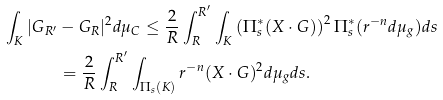<formula> <loc_0><loc_0><loc_500><loc_500>\int _ { K } | G _ { R ^ { \prime } } & - G _ { R } | ^ { 2 } d \mu _ { C } \leq \frac { 2 } { R } \int _ { R } ^ { R ^ { \prime } } \int _ { K } \left ( \Pi _ { s } ^ { * } ( X \cdot G ) \right ) ^ { 2 } \Pi _ { s } ^ { * } ( r ^ { - n } d \mu _ { g } ) d s \\ & = \frac { 2 } { R } \int _ { R } ^ { R ^ { \prime } } \int _ { \Pi _ { s } ( K ) } r ^ { - n } ( X \cdot G ) ^ { 2 } d \mu _ { g } d s .</formula> 